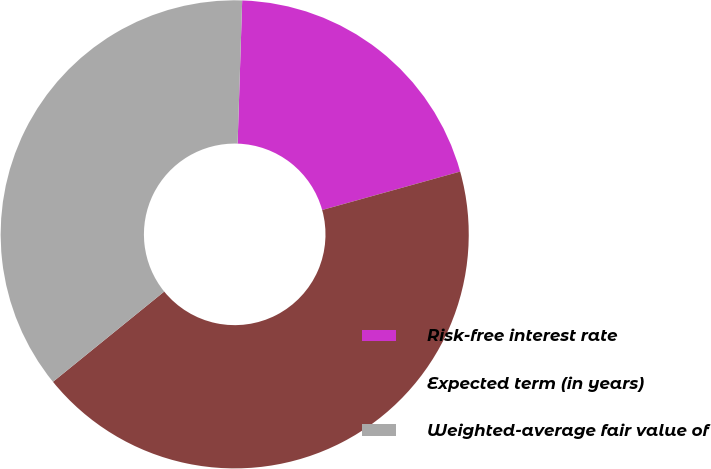<chart> <loc_0><loc_0><loc_500><loc_500><pie_chart><fcel>Risk-free interest rate<fcel>Expected term (in years)<fcel>Weighted-average fair value of<nl><fcel>20.17%<fcel>43.48%<fcel>36.36%<nl></chart> 